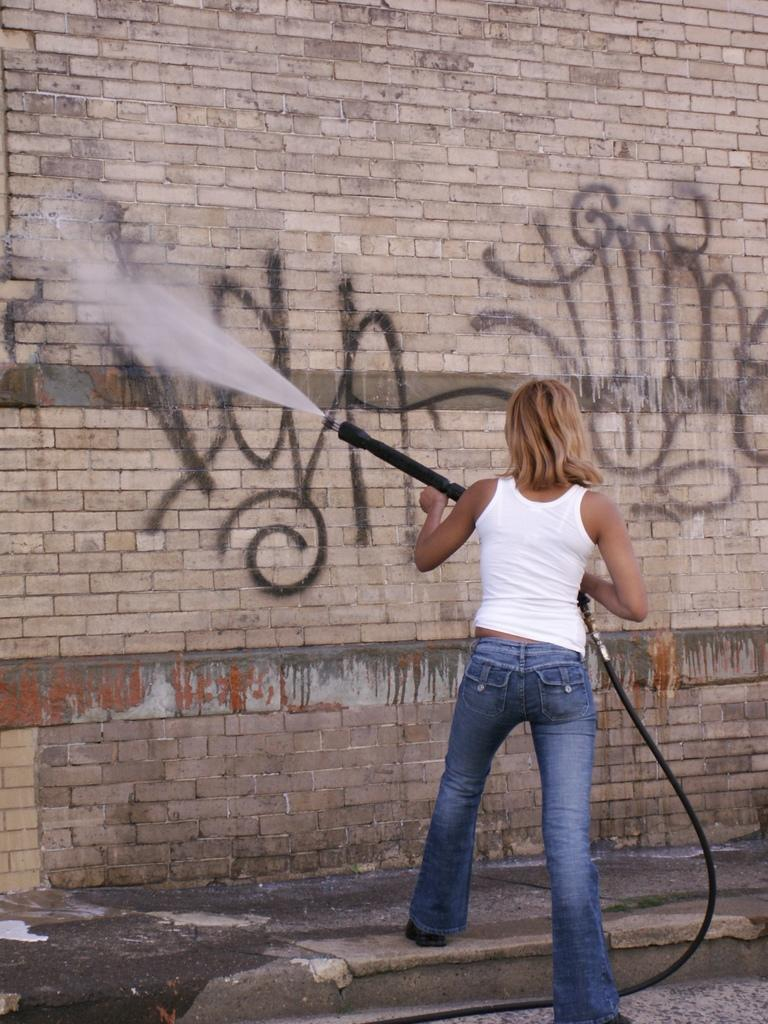What is the person in the image doing? The person is holding a pipe and spraying water. What is the person holding in the image? The person is holding a pipe. What can be seen in the background of the image? There is a brick wall in the background of the image. What is written on the brick wall? Something is written on the brick wall. What type of surface is at the bottom of the image? There is a sidewalk at the bottom of the image. What type of tooth can be seen in the image? There is no tooth present in the image. 